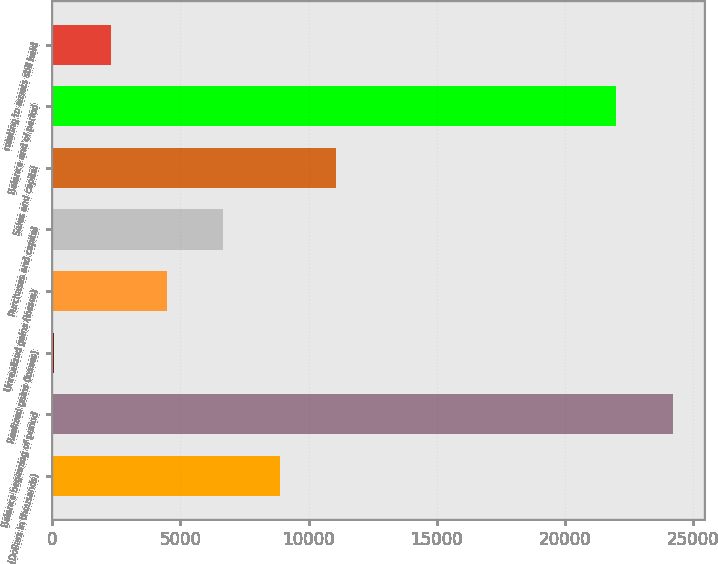<chart> <loc_0><loc_0><loc_500><loc_500><bar_chart><fcel>(Dollars in thousands)<fcel>Balance beginning of period<fcel>Realized gains (losses)<fcel>Unrealized gains (losses)<fcel>Purchases and capital<fcel>Sales and capital<fcel>Balance end of period<fcel>relating to assets still held<nl><fcel>8871.6<fcel>24207.9<fcel>84<fcel>4477.8<fcel>6674.7<fcel>11068.5<fcel>22011<fcel>2280.9<nl></chart> 